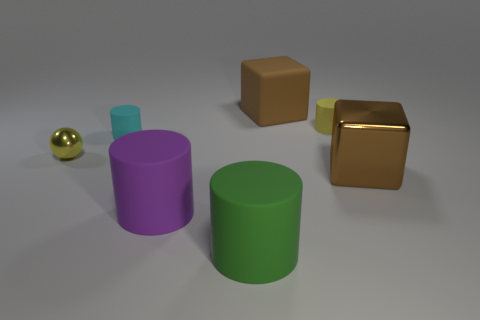What are the colors of the objects, and do they have any symbolic meanings? The objects are in varied colors: cyan, yellow, purple, green, and golden brown. While the colors themselves don't inherently carry symbolic meanings in this context, they can evoke different emotions and associations, such as calmness with cyan, warmth with yellow, and luxury with golden brown. 